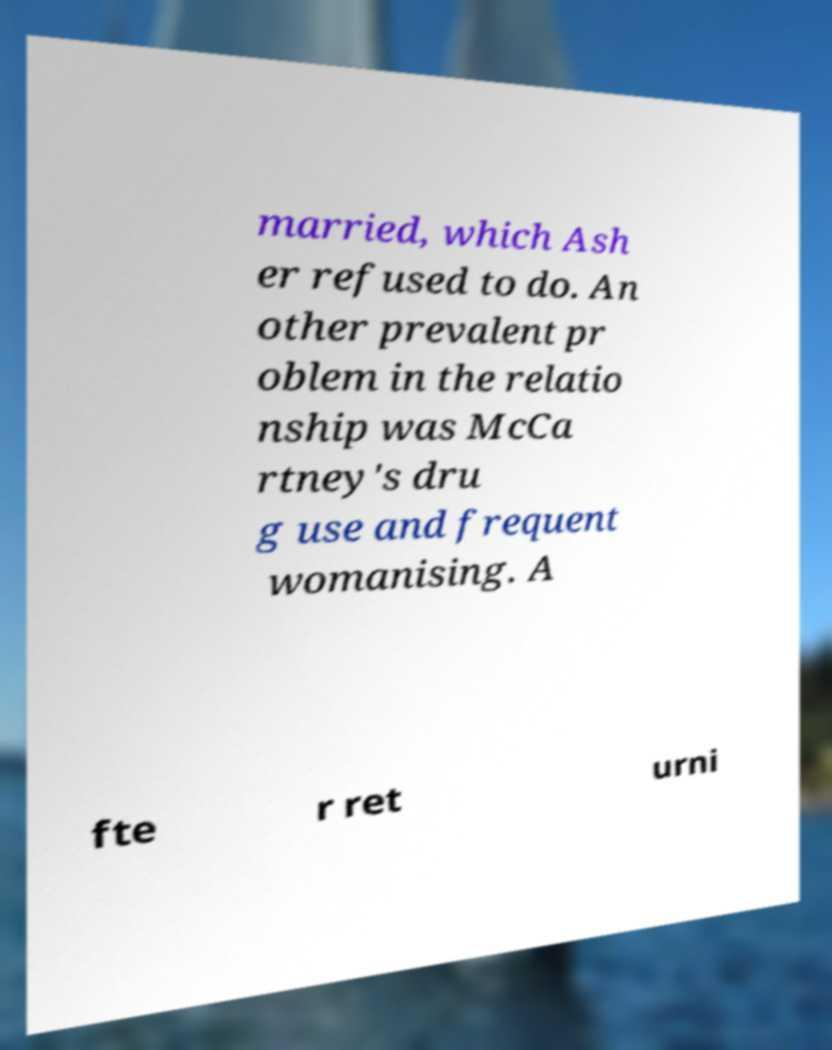Please identify and transcribe the text found in this image. married, which Ash er refused to do. An other prevalent pr oblem in the relatio nship was McCa rtney's dru g use and frequent womanising. A fte r ret urni 